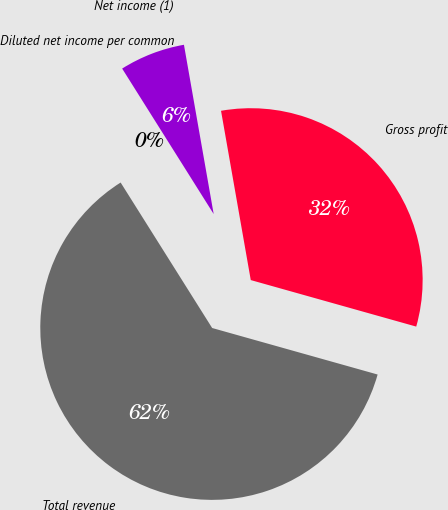<chart> <loc_0><loc_0><loc_500><loc_500><pie_chart><fcel>Total revenue<fcel>Gross profit<fcel>Net income (1)<fcel>Diluted net income per common<nl><fcel>61.7%<fcel>32.13%<fcel>6.17%<fcel>0.0%<nl></chart> 